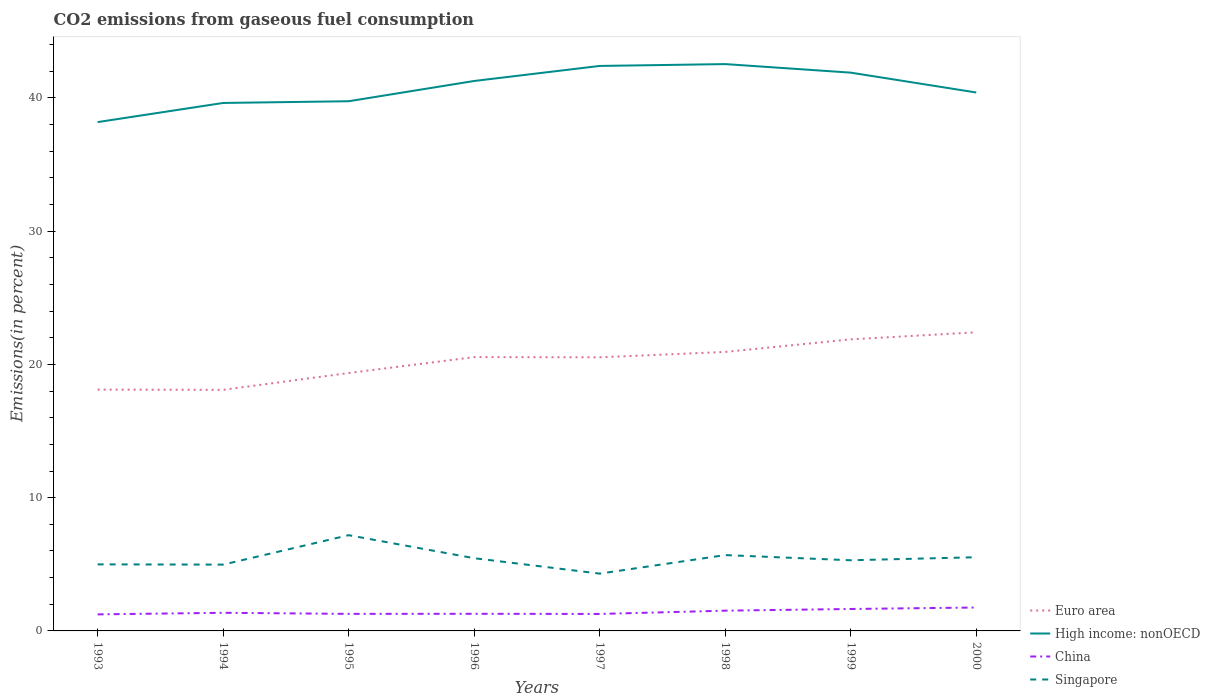How many different coloured lines are there?
Provide a short and direct response. 4. Does the line corresponding to High income: nonOECD intersect with the line corresponding to China?
Give a very brief answer. No. Across all years, what is the maximum total CO2 emitted in China?
Provide a short and direct response. 1.24. In which year was the total CO2 emitted in Euro area maximum?
Your response must be concise. 1994. What is the total total CO2 emitted in High income: nonOECD in the graph?
Offer a very short reply. -2.92. What is the difference between the highest and the second highest total CO2 emitted in High income: nonOECD?
Provide a short and direct response. 4.35. How many years are there in the graph?
Provide a succinct answer. 8. Are the values on the major ticks of Y-axis written in scientific E-notation?
Offer a very short reply. No. How many legend labels are there?
Offer a very short reply. 4. What is the title of the graph?
Make the answer very short. CO2 emissions from gaseous fuel consumption. What is the label or title of the X-axis?
Ensure brevity in your answer.  Years. What is the label or title of the Y-axis?
Give a very brief answer. Emissions(in percent). What is the Emissions(in percent) in Euro area in 1993?
Your answer should be compact. 18.11. What is the Emissions(in percent) of High income: nonOECD in 1993?
Your answer should be compact. 38.18. What is the Emissions(in percent) of China in 1993?
Keep it short and to the point. 1.24. What is the Emissions(in percent) of Singapore in 1993?
Give a very brief answer. 4.99. What is the Emissions(in percent) of Euro area in 1994?
Ensure brevity in your answer.  18.09. What is the Emissions(in percent) in High income: nonOECD in 1994?
Keep it short and to the point. 39.62. What is the Emissions(in percent) in China in 1994?
Offer a very short reply. 1.36. What is the Emissions(in percent) in Singapore in 1994?
Your response must be concise. 4.98. What is the Emissions(in percent) of Euro area in 1995?
Your answer should be compact. 19.35. What is the Emissions(in percent) of High income: nonOECD in 1995?
Give a very brief answer. 39.75. What is the Emissions(in percent) of China in 1995?
Ensure brevity in your answer.  1.28. What is the Emissions(in percent) of Singapore in 1995?
Keep it short and to the point. 7.18. What is the Emissions(in percent) of Euro area in 1996?
Keep it short and to the point. 20.55. What is the Emissions(in percent) of High income: nonOECD in 1996?
Offer a terse response. 41.27. What is the Emissions(in percent) in China in 1996?
Give a very brief answer. 1.29. What is the Emissions(in percent) of Singapore in 1996?
Your response must be concise. 5.46. What is the Emissions(in percent) of Euro area in 1997?
Offer a very short reply. 20.53. What is the Emissions(in percent) in High income: nonOECD in 1997?
Your answer should be compact. 42.4. What is the Emissions(in percent) of China in 1997?
Provide a short and direct response. 1.27. What is the Emissions(in percent) in Singapore in 1997?
Offer a terse response. 4.3. What is the Emissions(in percent) in Euro area in 1998?
Ensure brevity in your answer.  20.94. What is the Emissions(in percent) in High income: nonOECD in 1998?
Provide a short and direct response. 42.54. What is the Emissions(in percent) of China in 1998?
Make the answer very short. 1.52. What is the Emissions(in percent) of Singapore in 1998?
Offer a very short reply. 5.69. What is the Emissions(in percent) of Euro area in 1999?
Offer a very short reply. 21.88. What is the Emissions(in percent) of High income: nonOECD in 1999?
Keep it short and to the point. 41.89. What is the Emissions(in percent) in China in 1999?
Make the answer very short. 1.65. What is the Emissions(in percent) in Singapore in 1999?
Provide a succinct answer. 5.3. What is the Emissions(in percent) in Euro area in 2000?
Provide a short and direct response. 22.41. What is the Emissions(in percent) of High income: nonOECD in 2000?
Provide a short and direct response. 40.4. What is the Emissions(in percent) in China in 2000?
Ensure brevity in your answer.  1.76. What is the Emissions(in percent) in Singapore in 2000?
Make the answer very short. 5.53. Across all years, what is the maximum Emissions(in percent) in Euro area?
Give a very brief answer. 22.41. Across all years, what is the maximum Emissions(in percent) in High income: nonOECD?
Keep it short and to the point. 42.54. Across all years, what is the maximum Emissions(in percent) in China?
Ensure brevity in your answer.  1.76. Across all years, what is the maximum Emissions(in percent) of Singapore?
Give a very brief answer. 7.18. Across all years, what is the minimum Emissions(in percent) of Euro area?
Your answer should be very brief. 18.09. Across all years, what is the minimum Emissions(in percent) of High income: nonOECD?
Your answer should be very brief. 38.18. Across all years, what is the minimum Emissions(in percent) of China?
Your answer should be compact. 1.24. Across all years, what is the minimum Emissions(in percent) in Singapore?
Your answer should be compact. 4.3. What is the total Emissions(in percent) in Euro area in the graph?
Your answer should be compact. 161.86. What is the total Emissions(in percent) in High income: nonOECD in the graph?
Keep it short and to the point. 326.05. What is the total Emissions(in percent) of China in the graph?
Offer a terse response. 11.36. What is the total Emissions(in percent) of Singapore in the graph?
Ensure brevity in your answer.  43.43. What is the difference between the Emissions(in percent) of Euro area in 1993 and that in 1994?
Offer a terse response. 0.02. What is the difference between the Emissions(in percent) in High income: nonOECD in 1993 and that in 1994?
Your answer should be compact. -1.44. What is the difference between the Emissions(in percent) of China in 1993 and that in 1994?
Your response must be concise. -0.12. What is the difference between the Emissions(in percent) of Singapore in 1993 and that in 1994?
Offer a terse response. 0.02. What is the difference between the Emissions(in percent) of Euro area in 1993 and that in 1995?
Offer a terse response. -1.24. What is the difference between the Emissions(in percent) of High income: nonOECD in 1993 and that in 1995?
Your answer should be very brief. -1.57. What is the difference between the Emissions(in percent) in China in 1993 and that in 1995?
Your answer should be very brief. -0.04. What is the difference between the Emissions(in percent) of Singapore in 1993 and that in 1995?
Your response must be concise. -2.19. What is the difference between the Emissions(in percent) of Euro area in 1993 and that in 1996?
Provide a succinct answer. -2.44. What is the difference between the Emissions(in percent) in High income: nonOECD in 1993 and that in 1996?
Give a very brief answer. -3.09. What is the difference between the Emissions(in percent) in China in 1993 and that in 1996?
Give a very brief answer. -0.04. What is the difference between the Emissions(in percent) in Singapore in 1993 and that in 1996?
Offer a terse response. -0.46. What is the difference between the Emissions(in percent) of Euro area in 1993 and that in 1997?
Your answer should be very brief. -2.42. What is the difference between the Emissions(in percent) of High income: nonOECD in 1993 and that in 1997?
Your answer should be very brief. -4.22. What is the difference between the Emissions(in percent) in China in 1993 and that in 1997?
Keep it short and to the point. -0.03. What is the difference between the Emissions(in percent) of Singapore in 1993 and that in 1997?
Keep it short and to the point. 0.69. What is the difference between the Emissions(in percent) of Euro area in 1993 and that in 1998?
Offer a terse response. -2.83. What is the difference between the Emissions(in percent) in High income: nonOECD in 1993 and that in 1998?
Your answer should be very brief. -4.35. What is the difference between the Emissions(in percent) in China in 1993 and that in 1998?
Provide a short and direct response. -0.28. What is the difference between the Emissions(in percent) in Singapore in 1993 and that in 1998?
Your response must be concise. -0.7. What is the difference between the Emissions(in percent) in Euro area in 1993 and that in 1999?
Offer a terse response. -3.77. What is the difference between the Emissions(in percent) of High income: nonOECD in 1993 and that in 1999?
Your response must be concise. -3.71. What is the difference between the Emissions(in percent) in China in 1993 and that in 1999?
Ensure brevity in your answer.  -0.4. What is the difference between the Emissions(in percent) of Singapore in 1993 and that in 1999?
Make the answer very short. -0.31. What is the difference between the Emissions(in percent) in Euro area in 1993 and that in 2000?
Make the answer very short. -4.3. What is the difference between the Emissions(in percent) in High income: nonOECD in 1993 and that in 2000?
Give a very brief answer. -2.22. What is the difference between the Emissions(in percent) of China in 1993 and that in 2000?
Offer a very short reply. -0.52. What is the difference between the Emissions(in percent) in Singapore in 1993 and that in 2000?
Provide a succinct answer. -0.54. What is the difference between the Emissions(in percent) in Euro area in 1994 and that in 1995?
Make the answer very short. -1.26. What is the difference between the Emissions(in percent) in High income: nonOECD in 1994 and that in 1995?
Keep it short and to the point. -0.13. What is the difference between the Emissions(in percent) of China in 1994 and that in 1995?
Ensure brevity in your answer.  0.08. What is the difference between the Emissions(in percent) in Singapore in 1994 and that in 1995?
Provide a short and direct response. -2.21. What is the difference between the Emissions(in percent) of Euro area in 1994 and that in 1996?
Ensure brevity in your answer.  -2.46. What is the difference between the Emissions(in percent) in High income: nonOECD in 1994 and that in 1996?
Keep it short and to the point. -1.65. What is the difference between the Emissions(in percent) in China in 1994 and that in 1996?
Provide a succinct answer. 0.08. What is the difference between the Emissions(in percent) of Singapore in 1994 and that in 1996?
Keep it short and to the point. -0.48. What is the difference between the Emissions(in percent) of Euro area in 1994 and that in 1997?
Offer a very short reply. -2.44. What is the difference between the Emissions(in percent) of High income: nonOECD in 1994 and that in 1997?
Ensure brevity in your answer.  -2.78. What is the difference between the Emissions(in percent) in China in 1994 and that in 1997?
Offer a terse response. 0.09. What is the difference between the Emissions(in percent) in Singapore in 1994 and that in 1997?
Your answer should be very brief. 0.68. What is the difference between the Emissions(in percent) of Euro area in 1994 and that in 1998?
Your response must be concise. -2.84. What is the difference between the Emissions(in percent) in High income: nonOECD in 1994 and that in 1998?
Keep it short and to the point. -2.92. What is the difference between the Emissions(in percent) of China in 1994 and that in 1998?
Provide a short and direct response. -0.16. What is the difference between the Emissions(in percent) of Singapore in 1994 and that in 1998?
Make the answer very short. -0.71. What is the difference between the Emissions(in percent) in Euro area in 1994 and that in 1999?
Offer a terse response. -3.79. What is the difference between the Emissions(in percent) in High income: nonOECD in 1994 and that in 1999?
Offer a very short reply. -2.28. What is the difference between the Emissions(in percent) of China in 1994 and that in 1999?
Your answer should be very brief. -0.29. What is the difference between the Emissions(in percent) in Singapore in 1994 and that in 1999?
Your answer should be compact. -0.33. What is the difference between the Emissions(in percent) of Euro area in 1994 and that in 2000?
Your answer should be compact. -4.31. What is the difference between the Emissions(in percent) of High income: nonOECD in 1994 and that in 2000?
Give a very brief answer. -0.78. What is the difference between the Emissions(in percent) of China in 1994 and that in 2000?
Provide a succinct answer. -0.4. What is the difference between the Emissions(in percent) in Singapore in 1994 and that in 2000?
Give a very brief answer. -0.55. What is the difference between the Emissions(in percent) in Euro area in 1995 and that in 1996?
Your answer should be compact. -1.2. What is the difference between the Emissions(in percent) of High income: nonOECD in 1995 and that in 1996?
Make the answer very short. -1.52. What is the difference between the Emissions(in percent) in China in 1995 and that in 1996?
Your answer should be compact. -0.01. What is the difference between the Emissions(in percent) in Singapore in 1995 and that in 1996?
Provide a succinct answer. 1.73. What is the difference between the Emissions(in percent) in Euro area in 1995 and that in 1997?
Ensure brevity in your answer.  -1.18. What is the difference between the Emissions(in percent) of High income: nonOECD in 1995 and that in 1997?
Provide a short and direct response. -2.65. What is the difference between the Emissions(in percent) in China in 1995 and that in 1997?
Provide a short and direct response. 0.01. What is the difference between the Emissions(in percent) of Singapore in 1995 and that in 1997?
Give a very brief answer. 2.88. What is the difference between the Emissions(in percent) of Euro area in 1995 and that in 1998?
Your answer should be compact. -1.58. What is the difference between the Emissions(in percent) in High income: nonOECD in 1995 and that in 1998?
Offer a very short reply. -2.79. What is the difference between the Emissions(in percent) in China in 1995 and that in 1998?
Your answer should be compact. -0.24. What is the difference between the Emissions(in percent) in Singapore in 1995 and that in 1998?
Provide a succinct answer. 1.49. What is the difference between the Emissions(in percent) in Euro area in 1995 and that in 1999?
Provide a short and direct response. -2.53. What is the difference between the Emissions(in percent) of High income: nonOECD in 1995 and that in 1999?
Your answer should be compact. -2.15. What is the difference between the Emissions(in percent) of China in 1995 and that in 1999?
Offer a terse response. -0.37. What is the difference between the Emissions(in percent) in Singapore in 1995 and that in 1999?
Your answer should be compact. 1.88. What is the difference between the Emissions(in percent) in Euro area in 1995 and that in 2000?
Make the answer very short. -3.05. What is the difference between the Emissions(in percent) in High income: nonOECD in 1995 and that in 2000?
Your answer should be very brief. -0.66. What is the difference between the Emissions(in percent) of China in 1995 and that in 2000?
Your response must be concise. -0.48. What is the difference between the Emissions(in percent) of Singapore in 1995 and that in 2000?
Your response must be concise. 1.65. What is the difference between the Emissions(in percent) in Euro area in 1996 and that in 1997?
Offer a very short reply. 0.02. What is the difference between the Emissions(in percent) in High income: nonOECD in 1996 and that in 1997?
Ensure brevity in your answer.  -1.13. What is the difference between the Emissions(in percent) of China in 1996 and that in 1997?
Make the answer very short. 0.01. What is the difference between the Emissions(in percent) in Singapore in 1996 and that in 1997?
Your answer should be very brief. 1.16. What is the difference between the Emissions(in percent) in Euro area in 1996 and that in 1998?
Your answer should be very brief. -0.39. What is the difference between the Emissions(in percent) in High income: nonOECD in 1996 and that in 1998?
Ensure brevity in your answer.  -1.27. What is the difference between the Emissions(in percent) in China in 1996 and that in 1998?
Your answer should be compact. -0.24. What is the difference between the Emissions(in percent) of Singapore in 1996 and that in 1998?
Your answer should be very brief. -0.23. What is the difference between the Emissions(in percent) of Euro area in 1996 and that in 1999?
Give a very brief answer. -1.33. What is the difference between the Emissions(in percent) in High income: nonOECD in 1996 and that in 1999?
Your answer should be very brief. -0.63. What is the difference between the Emissions(in percent) of China in 1996 and that in 1999?
Make the answer very short. -0.36. What is the difference between the Emissions(in percent) in Singapore in 1996 and that in 1999?
Make the answer very short. 0.15. What is the difference between the Emissions(in percent) in Euro area in 1996 and that in 2000?
Your answer should be compact. -1.86. What is the difference between the Emissions(in percent) of High income: nonOECD in 1996 and that in 2000?
Keep it short and to the point. 0.86. What is the difference between the Emissions(in percent) in China in 1996 and that in 2000?
Your answer should be very brief. -0.47. What is the difference between the Emissions(in percent) in Singapore in 1996 and that in 2000?
Offer a terse response. -0.07. What is the difference between the Emissions(in percent) of Euro area in 1997 and that in 1998?
Your answer should be very brief. -0.4. What is the difference between the Emissions(in percent) of High income: nonOECD in 1997 and that in 1998?
Offer a terse response. -0.14. What is the difference between the Emissions(in percent) of China in 1997 and that in 1998?
Your response must be concise. -0.25. What is the difference between the Emissions(in percent) in Singapore in 1997 and that in 1998?
Your response must be concise. -1.39. What is the difference between the Emissions(in percent) of Euro area in 1997 and that in 1999?
Provide a succinct answer. -1.35. What is the difference between the Emissions(in percent) of High income: nonOECD in 1997 and that in 1999?
Keep it short and to the point. 0.5. What is the difference between the Emissions(in percent) of China in 1997 and that in 1999?
Your answer should be very brief. -0.37. What is the difference between the Emissions(in percent) in Singapore in 1997 and that in 1999?
Your answer should be compact. -1. What is the difference between the Emissions(in percent) of Euro area in 1997 and that in 2000?
Your answer should be very brief. -1.87. What is the difference between the Emissions(in percent) in High income: nonOECD in 1997 and that in 2000?
Your answer should be very brief. 1.99. What is the difference between the Emissions(in percent) in China in 1997 and that in 2000?
Offer a terse response. -0.48. What is the difference between the Emissions(in percent) of Singapore in 1997 and that in 2000?
Ensure brevity in your answer.  -1.23. What is the difference between the Emissions(in percent) of Euro area in 1998 and that in 1999?
Your answer should be compact. -0.94. What is the difference between the Emissions(in percent) of High income: nonOECD in 1998 and that in 1999?
Provide a succinct answer. 0.64. What is the difference between the Emissions(in percent) in China in 1998 and that in 1999?
Offer a terse response. -0.13. What is the difference between the Emissions(in percent) in Singapore in 1998 and that in 1999?
Provide a succinct answer. 0.39. What is the difference between the Emissions(in percent) in Euro area in 1998 and that in 2000?
Ensure brevity in your answer.  -1.47. What is the difference between the Emissions(in percent) of High income: nonOECD in 1998 and that in 2000?
Offer a very short reply. 2.13. What is the difference between the Emissions(in percent) in China in 1998 and that in 2000?
Your response must be concise. -0.24. What is the difference between the Emissions(in percent) in Singapore in 1998 and that in 2000?
Give a very brief answer. 0.16. What is the difference between the Emissions(in percent) in Euro area in 1999 and that in 2000?
Your response must be concise. -0.53. What is the difference between the Emissions(in percent) in High income: nonOECD in 1999 and that in 2000?
Keep it short and to the point. 1.49. What is the difference between the Emissions(in percent) of China in 1999 and that in 2000?
Offer a terse response. -0.11. What is the difference between the Emissions(in percent) of Singapore in 1999 and that in 2000?
Your answer should be very brief. -0.23. What is the difference between the Emissions(in percent) in Euro area in 1993 and the Emissions(in percent) in High income: nonOECD in 1994?
Offer a very short reply. -21.51. What is the difference between the Emissions(in percent) in Euro area in 1993 and the Emissions(in percent) in China in 1994?
Offer a very short reply. 16.75. What is the difference between the Emissions(in percent) of Euro area in 1993 and the Emissions(in percent) of Singapore in 1994?
Your answer should be very brief. 13.13. What is the difference between the Emissions(in percent) of High income: nonOECD in 1993 and the Emissions(in percent) of China in 1994?
Make the answer very short. 36.82. What is the difference between the Emissions(in percent) of High income: nonOECD in 1993 and the Emissions(in percent) of Singapore in 1994?
Your answer should be very brief. 33.21. What is the difference between the Emissions(in percent) of China in 1993 and the Emissions(in percent) of Singapore in 1994?
Ensure brevity in your answer.  -3.73. What is the difference between the Emissions(in percent) in Euro area in 1993 and the Emissions(in percent) in High income: nonOECD in 1995?
Give a very brief answer. -21.64. What is the difference between the Emissions(in percent) of Euro area in 1993 and the Emissions(in percent) of China in 1995?
Ensure brevity in your answer.  16.83. What is the difference between the Emissions(in percent) in Euro area in 1993 and the Emissions(in percent) in Singapore in 1995?
Offer a terse response. 10.92. What is the difference between the Emissions(in percent) of High income: nonOECD in 1993 and the Emissions(in percent) of China in 1995?
Your answer should be very brief. 36.9. What is the difference between the Emissions(in percent) in High income: nonOECD in 1993 and the Emissions(in percent) in Singapore in 1995?
Provide a short and direct response. 31. What is the difference between the Emissions(in percent) in China in 1993 and the Emissions(in percent) in Singapore in 1995?
Offer a very short reply. -5.94. What is the difference between the Emissions(in percent) of Euro area in 1993 and the Emissions(in percent) of High income: nonOECD in 1996?
Offer a terse response. -23.16. What is the difference between the Emissions(in percent) of Euro area in 1993 and the Emissions(in percent) of China in 1996?
Keep it short and to the point. 16.82. What is the difference between the Emissions(in percent) of Euro area in 1993 and the Emissions(in percent) of Singapore in 1996?
Make the answer very short. 12.65. What is the difference between the Emissions(in percent) in High income: nonOECD in 1993 and the Emissions(in percent) in China in 1996?
Your answer should be very brief. 36.9. What is the difference between the Emissions(in percent) in High income: nonOECD in 1993 and the Emissions(in percent) in Singapore in 1996?
Offer a very short reply. 32.73. What is the difference between the Emissions(in percent) in China in 1993 and the Emissions(in percent) in Singapore in 1996?
Provide a short and direct response. -4.21. What is the difference between the Emissions(in percent) in Euro area in 1993 and the Emissions(in percent) in High income: nonOECD in 1997?
Provide a short and direct response. -24.29. What is the difference between the Emissions(in percent) of Euro area in 1993 and the Emissions(in percent) of China in 1997?
Ensure brevity in your answer.  16.83. What is the difference between the Emissions(in percent) of Euro area in 1993 and the Emissions(in percent) of Singapore in 1997?
Your response must be concise. 13.81. What is the difference between the Emissions(in percent) in High income: nonOECD in 1993 and the Emissions(in percent) in China in 1997?
Your response must be concise. 36.91. What is the difference between the Emissions(in percent) in High income: nonOECD in 1993 and the Emissions(in percent) in Singapore in 1997?
Keep it short and to the point. 33.88. What is the difference between the Emissions(in percent) in China in 1993 and the Emissions(in percent) in Singapore in 1997?
Give a very brief answer. -3.06. What is the difference between the Emissions(in percent) of Euro area in 1993 and the Emissions(in percent) of High income: nonOECD in 1998?
Keep it short and to the point. -24.43. What is the difference between the Emissions(in percent) of Euro area in 1993 and the Emissions(in percent) of China in 1998?
Give a very brief answer. 16.59. What is the difference between the Emissions(in percent) of Euro area in 1993 and the Emissions(in percent) of Singapore in 1998?
Your answer should be compact. 12.42. What is the difference between the Emissions(in percent) in High income: nonOECD in 1993 and the Emissions(in percent) in China in 1998?
Ensure brevity in your answer.  36.66. What is the difference between the Emissions(in percent) in High income: nonOECD in 1993 and the Emissions(in percent) in Singapore in 1998?
Your response must be concise. 32.49. What is the difference between the Emissions(in percent) of China in 1993 and the Emissions(in percent) of Singapore in 1998?
Offer a terse response. -4.45. What is the difference between the Emissions(in percent) of Euro area in 1993 and the Emissions(in percent) of High income: nonOECD in 1999?
Offer a terse response. -23.79. What is the difference between the Emissions(in percent) of Euro area in 1993 and the Emissions(in percent) of China in 1999?
Your answer should be very brief. 16.46. What is the difference between the Emissions(in percent) in Euro area in 1993 and the Emissions(in percent) in Singapore in 1999?
Keep it short and to the point. 12.81. What is the difference between the Emissions(in percent) in High income: nonOECD in 1993 and the Emissions(in percent) in China in 1999?
Ensure brevity in your answer.  36.54. What is the difference between the Emissions(in percent) of High income: nonOECD in 1993 and the Emissions(in percent) of Singapore in 1999?
Give a very brief answer. 32.88. What is the difference between the Emissions(in percent) of China in 1993 and the Emissions(in percent) of Singapore in 1999?
Your answer should be compact. -4.06. What is the difference between the Emissions(in percent) of Euro area in 1993 and the Emissions(in percent) of High income: nonOECD in 2000?
Your answer should be compact. -22.3. What is the difference between the Emissions(in percent) in Euro area in 1993 and the Emissions(in percent) in China in 2000?
Keep it short and to the point. 16.35. What is the difference between the Emissions(in percent) in Euro area in 1993 and the Emissions(in percent) in Singapore in 2000?
Your answer should be very brief. 12.58. What is the difference between the Emissions(in percent) of High income: nonOECD in 1993 and the Emissions(in percent) of China in 2000?
Provide a succinct answer. 36.43. What is the difference between the Emissions(in percent) of High income: nonOECD in 1993 and the Emissions(in percent) of Singapore in 2000?
Provide a succinct answer. 32.65. What is the difference between the Emissions(in percent) of China in 1993 and the Emissions(in percent) of Singapore in 2000?
Keep it short and to the point. -4.29. What is the difference between the Emissions(in percent) in Euro area in 1994 and the Emissions(in percent) in High income: nonOECD in 1995?
Your answer should be compact. -21.66. What is the difference between the Emissions(in percent) in Euro area in 1994 and the Emissions(in percent) in China in 1995?
Offer a terse response. 16.81. What is the difference between the Emissions(in percent) of Euro area in 1994 and the Emissions(in percent) of Singapore in 1995?
Your answer should be very brief. 10.91. What is the difference between the Emissions(in percent) in High income: nonOECD in 1994 and the Emissions(in percent) in China in 1995?
Provide a short and direct response. 38.34. What is the difference between the Emissions(in percent) of High income: nonOECD in 1994 and the Emissions(in percent) of Singapore in 1995?
Provide a succinct answer. 32.44. What is the difference between the Emissions(in percent) of China in 1994 and the Emissions(in percent) of Singapore in 1995?
Provide a short and direct response. -5.82. What is the difference between the Emissions(in percent) of Euro area in 1994 and the Emissions(in percent) of High income: nonOECD in 1996?
Offer a very short reply. -23.18. What is the difference between the Emissions(in percent) of Euro area in 1994 and the Emissions(in percent) of China in 1996?
Ensure brevity in your answer.  16.81. What is the difference between the Emissions(in percent) of Euro area in 1994 and the Emissions(in percent) of Singapore in 1996?
Your answer should be very brief. 12.64. What is the difference between the Emissions(in percent) in High income: nonOECD in 1994 and the Emissions(in percent) in China in 1996?
Your answer should be compact. 38.33. What is the difference between the Emissions(in percent) of High income: nonOECD in 1994 and the Emissions(in percent) of Singapore in 1996?
Ensure brevity in your answer.  34.16. What is the difference between the Emissions(in percent) of China in 1994 and the Emissions(in percent) of Singapore in 1996?
Your response must be concise. -4.1. What is the difference between the Emissions(in percent) of Euro area in 1994 and the Emissions(in percent) of High income: nonOECD in 1997?
Offer a terse response. -24.31. What is the difference between the Emissions(in percent) of Euro area in 1994 and the Emissions(in percent) of China in 1997?
Your response must be concise. 16.82. What is the difference between the Emissions(in percent) of Euro area in 1994 and the Emissions(in percent) of Singapore in 1997?
Your answer should be very brief. 13.79. What is the difference between the Emissions(in percent) in High income: nonOECD in 1994 and the Emissions(in percent) in China in 1997?
Provide a short and direct response. 38.35. What is the difference between the Emissions(in percent) in High income: nonOECD in 1994 and the Emissions(in percent) in Singapore in 1997?
Offer a terse response. 35.32. What is the difference between the Emissions(in percent) of China in 1994 and the Emissions(in percent) of Singapore in 1997?
Make the answer very short. -2.94. What is the difference between the Emissions(in percent) of Euro area in 1994 and the Emissions(in percent) of High income: nonOECD in 1998?
Make the answer very short. -24.44. What is the difference between the Emissions(in percent) of Euro area in 1994 and the Emissions(in percent) of China in 1998?
Provide a short and direct response. 16.57. What is the difference between the Emissions(in percent) in Euro area in 1994 and the Emissions(in percent) in Singapore in 1998?
Your answer should be very brief. 12.4. What is the difference between the Emissions(in percent) of High income: nonOECD in 1994 and the Emissions(in percent) of China in 1998?
Provide a short and direct response. 38.1. What is the difference between the Emissions(in percent) of High income: nonOECD in 1994 and the Emissions(in percent) of Singapore in 1998?
Your answer should be compact. 33.93. What is the difference between the Emissions(in percent) in China in 1994 and the Emissions(in percent) in Singapore in 1998?
Give a very brief answer. -4.33. What is the difference between the Emissions(in percent) in Euro area in 1994 and the Emissions(in percent) in High income: nonOECD in 1999?
Make the answer very short. -23.8. What is the difference between the Emissions(in percent) in Euro area in 1994 and the Emissions(in percent) in China in 1999?
Ensure brevity in your answer.  16.45. What is the difference between the Emissions(in percent) of Euro area in 1994 and the Emissions(in percent) of Singapore in 1999?
Offer a terse response. 12.79. What is the difference between the Emissions(in percent) of High income: nonOECD in 1994 and the Emissions(in percent) of China in 1999?
Offer a very short reply. 37.97. What is the difference between the Emissions(in percent) in High income: nonOECD in 1994 and the Emissions(in percent) in Singapore in 1999?
Make the answer very short. 34.32. What is the difference between the Emissions(in percent) in China in 1994 and the Emissions(in percent) in Singapore in 1999?
Your response must be concise. -3.94. What is the difference between the Emissions(in percent) in Euro area in 1994 and the Emissions(in percent) in High income: nonOECD in 2000?
Provide a succinct answer. -22.31. What is the difference between the Emissions(in percent) of Euro area in 1994 and the Emissions(in percent) of China in 2000?
Your response must be concise. 16.33. What is the difference between the Emissions(in percent) of Euro area in 1994 and the Emissions(in percent) of Singapore in 2000?
Your answer should be very brief. 12.56. What is the difference between the Emissions(in percent) in High income: nonOECD in 1994 and the Emissions(in percent) in China in 2000?
Provide a short and direct response. 37.86. What is the difference between the Emissions(in percent) of High income: nonOECD in 1994 and the Emissions(in percent) of Singapore in 2000?
Offer a very short reply. 34.09. What is the difference between the Emissions(in percent) in China in 1994 and the Emissions(in percent) in Singapore in 2000?
Provide a short and direct response. -4.17. What is the difference between the Emissions(in percent) of Euro area in 1995 and the Emissions(in percent) of High income: nonOECD in 1996?
Keep it short and to the point. -21.92. What is the difference between the Emissions(in percent) of Euro area in 1995 and the Emissions(in percent) of China in 1996?
Provide a short and direct response. 18.07. What is the difference between the Emissions(in percent) of Euro area in 1995 and the Emissions(in percent) of Singapore in 1996?
Offer a terse response. 13.9. What is the difference between the Emissions(in percent) in High income: nonOECD in 1995 and the Emissions(in percent) in China in 1996?
Offer a very short reply. 38.46. What is the difference between the Emissions(in percent) of High income: nonOECD in 1995 and the Emissions(in percent) of Singapore in 1996?
Your answer should be very brief. 34.29. What is the difference between the Emissions(in percent) in China in 1995 and the Emissions(in percent) in Singapore in 1996?
Your answer should be compact. -4.18. What is the difference between the Emissions(in percent) of Euro area in 1995 and the Emissions(in percent) of High income: nonOECD in 1997?
Your answer should be compact. -23.05. What is the difference between the Emissions(in percent) of Euro area in 1995 and the Emissions(in percent) of China in 1997?
Offer a very short reply. 18.08. What is the difference between the Emissions(in percent) in Euro area in 1995 and the Emissions(in percent) in Singapore in 1997?
Ensure brevity in your answer.  15.05. What is the difference between the Emissions(in percent) of High income: nonOECD in 1995 and the Emissions(in percent) of China in 1997?
Provide a succinct answer. 38.48. What is the difference between the Emissions(in percent) of High income: nonOECD in 1995 and the Emissions(in percent) of Singapore in 1997?
Make the answer very short. 35.45. What is the difference between the Emissions(in percent) in China in 1995 and the Emissions(in percent) in Singapore in 1997?
Keep it short and to the point. -3.02. What is the difference between the Emissions(in percent) in Euro area in 1995 and the Emissions(in percent) in High income: nonOECD in 1998?
Offer a very short reply. -23.18. What is the difference between the Emissions(in percent) in Euro area in 1995 and the Emissions(in percent) in China in 1998?
Your answer should be compact. 17.83. What is the difference between the Emissions(in percent) of Euro area in 1995 and the Emissions(in percent) of Singapore in 1998?
Provide a short and direct response. 13.66. What is the difference between the Emissions(in percent) in High income: nonOECD in 1995 and the Emissions(in percent) in China in 1998?
Keep it short and to the point. 38.23. What is the difference between the Emissions(in percent) of High income: nonOECD in 1995 and the Emissions(in percent) of Singapore in 1998?
Your answer should be very brief. 34.06. What is the difference between the Emissions(in percent) in China in 1995 and the Emissions(in percent) in Singapore in 1998?
Provide a succinct answer. -4.41. What is the difference between the Emissions(in percent) of Euro area in 1995 and the Emissions(in percent) of High income: nonOECD in 1999?
Provide a succinct answer. -22.54. What is the difference between the Emissions(in percent) of Euro area in 1995 and the Emissions(in percent) of China in 1999?
Offer a very short reply. 17.71. What is the difference between the Emissions(in percent) in Euro area in 1995 and the Emissions(in percent) in Singapore in 1999?
Make the answer very short. 14.05. What is the difference between the Emissions(in percent) in High income: nonOECD in 1995 and the Emissions(in percent) in China in 1999?
Give a very brief answer. 38.1. What is the difference between the Emissions(in percent) of High income: nonOECD in 1995 and the Emissions(in percent) of Singapore in 1999?
Your answer should be very brief. 34.45. What is the difference between the Emissions(in percent) of China in 1995 and the Emissions(in percent) of Singapore in 1999?
Your answer should be very brief. -4.02. What is the difference between the Emissions(in percent) of Euro area in 1995 and the Emissions(in percent) of High income: nonOECD in 2000?
Provide a short and direct response. -21.05. What is the difference between the Emissions(in percent) in Euro area in 1995 and the Emissions(in percent) in China in 2000?
Your answer should be compact. 17.6. What is the difference between the Emissions(in percent) of Euro area in 1995 and the Emissions(in percent) of Singapore in 2000?
Your response must be concise. 13.82. What is the difference between the Emissions(in percent) in High income: nonOECD in 1995 and the Emissions(in percent) in China in 2000?
Give a very brief answer. 37.99. What is the difference between the Emissions(in percent) of High income: nonOECD in 1995 and the Emissions(in percent) of Singapore in 2000?
Offer a terse response. 34.22. What is the difference between the Emissions(in percent) in China in 1995 and the Emissions(in percent) in Singapore in 2000?
Give a very brief answer. -4.25. What is the difference between the Emissions(in percent) of Euro area in 1996 and the Emissions(in percent) of High income: nonOECD in 1997?
Offer a terse response. -21.85. What is the difference between the Emissions(in percent) of Euro area in 1996 and the Emissions(in percent) of China in 1997?
Your answer should be very brief. 19.27. What is the difference between the Emissions(in percent) in Euro area in 1996 and the Emissions(in percent) in Singapore in 1997?
Provide a short and direct response. 16.25. What is the difference between the Emissions(in percent) in High income: nonOECD in 1996 and the Emissions(in percent) in China in 1997?
Offer a terse response. 39.99. What is the difference between the Emissions(in percent) of High income: nonOECD in 1996 and the Emissions(in percent) of Singapore in 1997?
Give a very brief answer. 36.97. What is the difference between the Emissions(in percent) in China in 1996 and the Emissions(in percent) in Singapore in 1997?
Ensure brevity in your answer.  -3.02. What is the difference between the Emissions(in percent) of Euro area in 1996 and the Emissions(in percent) of High income: nonOECD in 1998?
Provide a short and direct response. -21.99. What is the difference between the Emissions(in percent) in Euro area in 1996 and the Emissions(in percent) in China in 1998?
Ensure brevity in your answer.  19.03. What is the difference between the Emissions(in percent) of Euro area in 1996 and the Emissions(in percent) of Singapore in 1998?
Offer a very short reply. 14.86. What is the difference between the Emissions(in percent) in High income: nonOECD in 1996 and the Emissions(in percent) in China in 1998?
Ensure brevity in your answer.  39.75. What is the difference between the Emissions(in percent) in High income: nonOECD in 1996 and the Emissions(in percent) in Singapore in 1998?
Provide a short and direct response. 35.58. What is the difference between the Emissions(in percent) of China in 1996 and the Emissions(in percent) of Singapore in 1998?
Keep it short and to the point. -4.4. What is the difference between the Emissions(in percent) in Euro area in 1996 and the Emissions(in percent) in High income: nonOECD in 1999?
Your answer should be very brief. -21.35. What is the difference between the Emissions(in percent) in Euro area in 1996 and the Emissions(in percent) in China in 1999?
Provide a succinct answer. 18.9. What is the difference between the Emissions(in percent) of Euro area in 1996 and the Emissions(in percent) of Singapore in 1999?
Your response must be concise. 15.25. What is the difference between the Emissions(in percent) in High income: nonOECD in 1996 and the Emissions(in percent) in China in 1999?
Offer a terse response. 39.62. What is the difference between the Emissions(in percent) in High income: nonOECD in 1996 and the Emissions(in percent) in Singapore in 1999?
Ensure brevity in your answer.  35.97. What is the difference between the Emissions(in percent) in China in 1996 and the Emissions(in percent) in Singapore in 1999?
Provide a succinct answer. -4.02. What is the difference between the Emissions(in percent) of Euro area in 1996 and the Emissions(in percent) of High income: nonOECD in 2000?
Keep it short and to the point. -19.86. What is the difference between the Emissions(in percent) in Euro area in 1996 and the Emissions(in percent) in China in 2000?
Provide a short and direct response. 18.79. What is the difference between the Emissions(in percent) in Euro area in 1996 and the Emissions(in percent) in Singapore in 2000?
Your answer should be very brief. 15.02. What is the difference between the Emissions(in percent) in High income: nonOECD in 1996 and the Emissions(in percent) in China in 2000?
Your answer should be compact. 39.51. What is the difference between the Emissions(in percent) in High income: nonOECD in 1996 and the Emissions(in percent) in Singapore in 2000?
Keep it short and to the point. 35.74. What is the difference between the Emissions(in percent) of China in 1996 and the Emissions(in percent) of Singapore in 2000?
Give a very brief answer. -4.24. What is the difference between the Emissions(in percent) in Euro area in 1997 and the Emissions(in percent) in High income: nonOECD in 1998?
Your answer should be very brief. -22. What is the difference between the Emissions(in percent) in Euro area in 1997 and the Emissions(in percent) in China in 1998?
Your response must be concise. 19.01. What is the difference between the Emissions(in percent) in Euro area in 1997 and the Emissions(in percent) in Singapore in 1998?
Your response must be concise. 14.84. What is the difference between the Emissions(in percent) in High income: nonOECD in 1997 and the Emissions(in percent) in China in 1998?
Make the answer very short. 40.88. What is the difference between the Emissions(in percent) of High income: nonOECD in 1997 and the Emissions(in percent) of Singapore in 1998?
Offer a terse response. 36.71. What is the difference between the Emissions(in percent) in China in 1997 and the Emissions(in percent) in Singapore in 1998?
Provide a short and direct response. -4.42. What is the difference between the Emissions(in percent) in Euro area in 1997 and the Emissions(in percent) in High income: nonOECD in 1999?
Your response must be concise. -21.36. What is the difference between the Emissions(in percent) in Euro area in 1997 and the Emissions(in percent) in China in 1999?
Provide a succinct answer. 18.89. What is the difference between the Emissions(in percent) in Euro area in 1997 and the Emissions(in percent) in Singapore in 1999?
Provide a short and direct response. 15.23. What is the difference between the Emissions(in percent) of High income: nonOECD in 1997 and the Emissions(in percent) of China in 1999?
Offer a terse response. 40.75. What is the difference between the Emissions(in percent) of High income: nonOECD in 1997 and the Emissions(in percent) of Singapore in 1999?
Make the answer very short. 37.1. What is the difference between the Emissions(in percent) in China in 1997 and the Emissions(in percent) in Singapore in 1999?
Make the answer very short. -4.03. What is the difference between the Emissions(in percent) in Euro area in 1997 and the Emissions(in percent) in High income: nonOECD in 2000?
Offer a very short reply. -19.87. What is the difference between the Emissions(in percent) in Euro area in 1997 and the Emissions(in percent) in China in 2000?
Your answer should be compact. 18.77. What is the difference between the Emissions(in percent) of Euro area in 1997 and the Emissions(in percent) of Singapore in 2000?
Make the answer very short. 15. What is the difference between the Emissions(in percent) in High income: nonOECD in 1997 and the Emissions(in percent) in China in 2000?
Make the answer very short. 40.64. What is the difference between the Emissions(in percent) in High income: nonOECD in 1997 and the Emissions(in percent) in Singapore in 2000?
Provide a short and direct response. 36.87. What is the difference between the Emissions(in percent) in China in 1997 and the Emissions(in percent) in Singapore in 2000?
Keep it short and to the point. -4.26. What is the difference between the Emissions(in percent) of Euro area in 1998 and the Emissions(in percent) of High income: nonOECD in 1999?
Make the answer very short. -20.96. What is the difference between the Emissions(in percent) of Euro area in 1998 and the Emissions(in percent) of China in 1999?
Offer a terse response. 19.29. What is the difference between the Emissions(in percent) in Euro area in 1998 and the Emissions(in percent) in Singapore in 1999?
Offer a terse response. 15.63. What is the difference between the Emissions(in percent) in High income: nonOECD in 1998 and the Emissions(in percent) in China in 1999?
Your answer should be compact. 40.89. What is the difference between the Emissions(in percent) in High income: nonOECD in 1998 and the Emissions(in percent) in Singapore in 1999?
Provide a succinct answer. 37.23. What is the difference between the Emissions(in percent) in China in 1998 and the Emissions(in percent) in Singapore in 1999?
Your answer should be compact. -3.78. What is the difference between the Emissions(in percent) in Euro area in 1998 and the Emissions(in percent) in High income: nonOECD in 2000?
Provide a succinct answer. -19.47. What is the difference between the Emissions(in percent) in Euro area in 1998 and the Emissions(in percent) in China in 2000?
Provide a succinct answer. 19.18. What is the difference between the Emissions(in percent) of Euro area in 1998 and the Emissions(in percent) of Singapore in 2000?
Ensure brevity in your answer.  15.41. What is the difference between the Emissions(in percent) of High income: nonOECD in 1998 and the Emissions(in percent) of China in 2000?
Offer a terse response. 40.78. What is the difference between the Emissions(in percent) in High income: nonOECD in 1998 and the Emissions(in percent) in Singapore in 2000?
Make the answer very short. 37.01. What is the difference between the Emissions(in percent) of China in 1998 and the Emissions(in percent) of Singapore in 2000?
Your response must be concise. -4.01. What is the difference between the Emissions(in percent) in Euro area in 1999 and the Emissions(in percent) in High income: nonOECD in 2000?
Offer a very short reply. -18.52. What is the difference between the Emissions(in percent) of Euro area in 1999 and the Emissions(in percent) of China in 2000?
Your response must be concise. 20.12. What is the difference between the Emissions(in percent) in Euro area in 1999 and the Emissions(in percent) in Singapore in 2000?
Provide a short and direct response. 16.35. What is the difference between the Emissions(in percent) of High income: nonOECD in 1999 and the Emissions(in percent) of China in 2000?
Your response must be concise. 40.14. What is the difference between the Emissions(in percent) of High income: nonOECD in 1999 and the Emissions(in percent) of Singapore in 2000?
Provide a short and direct response. 36.37. What is the difference between the Emissions(in percent) of China in 1999 and the Emissions(in percent) of Singapore in 2000?
Keep it short and to the point. -3.88. What is the average Emissions(in percent) in Euro area per year?
Give a very brief answer. 20.23. What is the average Emissions(in percent) in High income: nonOECD per year?
Give a very brief answer. 40.76. What is the average Emissions(in percent) of China per year?
Offer a terse response. 1.42. What is the average Emissions(in percent) of Singapore per year?
Ensure brevity in your answer.  5.43. In the year 1993, what is the difference between the Emissions(in percent) in Euro area and Emissions(in percent) in High income: nonOECD?
Your answer should be compact. -20.07. In the year 1993, what is the difference between the Emissions(in percent) in Euro area and Emissions(in percent) in China?
Your response must be concise. 16.87. In the year 1993, what is the difference between the Emissions(in percent) in Euro area and Emissions(in percent) in Singapore?
Offer a very short reply. 13.11. In the year 1993, what is the difference between the Emissions(in percent) in High income: nonOECD and Emissions(in percent) in China?
Offer a very short reply. 36.94. In the year 1993, what is the difference between the Emissions(in percent) in High income: nonOECD and Emissions(in percent) in Singapore?
Offer a terse response. 33.19. In the year 1993, what is the difference between the Emissions(in percent) of China and Emissions(in percent) of Singapore?
Your answer should be very brief. -3.75. In the year 1994, what is the difference between the Emissions(in percent) of Euro area and Emissions(in percent) of High income: nonOECD?
Make the answer very short. -21.53. In the year 1994, what is the difference between the Emissions(in percent) of Euro area and Emissions(in percent) of China?
Ensure brevity in your answer.  16.73. In the year 1994, what is the difference between the Emissions(in percent) of Euro area and Emissions(in percent) of Singapore?
Your answer should be compact. 13.12. In the year 1994, what is the difference between the Emissions(in percent) in High income: nonOECD and Emissions(in percent) in China?
Provide a succinct answer. 38.26. In the year 1994, what is the difference between the Emissions(in percent) of High income: nonOECD and Emissions(in percent) of Singapore?
Your answer should be compact. 34.64. In the year 1994, what is the difference between the Emissions(in percent) in China and Emissions(in percent) in Singapore?
Provide a short and direct response. -3.62. In the year 1995, what is the difference between the Emissions(in percent) of Euro area and Emissions(in percent) of High income: nonOECD?
Ensure brevity in your answer.  -20.4. In the year 1995, what is the difference between the Emissions(in percent) of Euro area and Emissions(in percent) of China?
Offer a very short reply. 18.07. In the year 1995, what is the difference between the Emissions(in percent) in Euro area and Emissions(in percent) in Singapore?
Your answer should be very brief. 12.17. In the year 1995, what is the difference between the Emissions(in percent) of High income: nonOECD and Emissions(in percent) of China?
Your answer should be very brief. 38.47. In the year 1995, what is the difference between the Emissions(in percent) in High income: nonOECD and Emissions(in percent) in Singapore?
Your response must be concise. 32.56. In the year 1995, what is the difference between the Emissions(in percent) of China and Emissions(in percent) of Singapore?
Offer a terse response. -5.91. In the year 1996, what is the difference between the Emissions(in percent) in Euro area and Emissions(in percent) in High income: nonOECD?
Give a very brief answer. -20.72. In the year 1996, what is the difference between the Emissions(in percent) of Euro area and Emissions(in percent) of China?
Ensure brevity in your answer.  19.26. In the year 1996, what is the difference between the Emissions(in percent) of Euro area and Emissions(in percent) of Singapore?
Give a very brief answer. 15.09. In the year 1996, what is the difference between the Emissions(in percent) in High income: nonOECD and Emissions(in percent) in China?
Offer a terse response. 39.98. In the year 1996, what is the difference between the Emissions(in percent) of High income: nonOECD and Emissions(in percent) of Singapore?
Your response must be concise. 35.81. In the year 1996, what is the difference between the Emissions(in percent) in China and Emissions(in percent) in Singapore?
Ensure brevity in your answer.  -4.17. In the year 1997, what is the difference between the Emissions(in percent) in Euro area and Emissions(in percent) in High income: nonOECD?
Your response must be concise. -21.87. In the year 1997, what is the difference between the Emissions(in percent) in Euro area and Emissions(in percent) in China?
Make the answer very short. 19.26. In the year 1997, what is the difference between the Emissions(in percent) in Euro area and Emissions(in percent) in Singapore?
Your answer should be very brief. 16.23. In the year 1997, what is the difference between the Emissions(in percent) of High income: nonOECD and Emissions(in percent) of China?
Provide a short and direct response. 41.12. In the year 1997, what is the difference between the Emissions(in percent) in High income: nonOECD and Emissions(in percent) in Singapore?
Keep it short and to the point. 38.1. In the year 1997, what is the difference between the Emissions(in percent) in China and Emissions(in percent) in Singapore?
Make the answer very short. -3.03. In the year 1998, what is the difference between the Emissions(in percent) in Euro area and Emissions(in percent) in High income: nonOECD?
Provide a short and direct response. -21.6. In the year 1998, what is the difference between the Emissions(in percent) of Euro area and Emissions(in percent) of China?
Keep it short and to the point. 19.42. In the year 1998, what is the difference between the Emissions(in percent) of Euro area and Emissions(in percent) of Singapore?
Offer a terse response. 15.25. In the year 1998, what is the difference between the Emissions(in percent) of High income: nonOECD and Emissions(in percent) of China?
Your answer should be very brief. 41.02. In the year 1998, what is the difference between the Emissions(in percent) of High income: nonOECD and Emissions(in percent) of Singapore?
Keep it short and to the point. 36.85. In the year 1998, what is the difference between the Emissions(in percent) of China and Emissions(in percent) of Singapore?
Make the answer very short. -4.17. In the year 1999, what is the difference between the Emissions(in percent) in Euro area and Emissions(in percent) in High income: nonOECD?
Provide a succinct answer. -20.01. In the year 1999, what is the difference between the Emissions(in percent) in Euro area and Emissions(in percent) in China?
Offer a terse response. 20.23. In the year 1999, what is the difference between the Emissions(in percent) of Euro area and Emissions(in percent) of Singapore?
Make the answer very short. 16.58. In the year 1999, what is the difference between the Emissions(in percent) in High income: nonOECD and Emissions(in percent) in China?
Your answer should be compact. 40.25. In the year 1999, what is the difference between the Emissions(in percent) in High income: nonOECD and Emissions(in percent) in Singapore?
Ensure brevity in your answer.  36.59. In the year 1999, what is the difference between the Emissions(in percent) of China and Emissions(in percent) of Singapore?
Offer a terse response. -3.66. In the year 2000, what is the difference between the Emissions(in percent) of Euro area and Emissions(in percent) of High income: nonOECD?
Ensure brevity in your answer.  -18. In the year 2000, what is the difference between the Emissions(in percent) of Euro area and Emissions(in percent) of China?
Ensure brevity in your answer.  20.65. In the year 2000, what is the difference between the Emissions(in percent) in Euro area and Emissions(in percent) in Singapore?
Offer a very short reply. 16.88. In the year 2000, what is the difference between the Emissions(in percent) of High income: nonOECD and Emissions(in percent) of China?
Provide a succinct answer. 38.65. In the year 2000, what is the difference between the Emissions(in percent) of High income: nonOECD and Emissions(in percent) of Singapore?
Offer a terse response. 34.87. In the year 2000, what is the difference between the Emissions(in percent) of China and Emissions(in percent) of Singapore?
Ensure brevity in your answer.  -3.77. What is the ratio of the Emissions(in percent) in High income: nonOECD in 1993 to that in 1994?
Offer a terse response. 0.96. What is the ratio of the Emissions(in percent) of China in 1993 to that in 1994?
Provide a succinct answer. 0.91. What is the ratio of the Emissions(in percent) in Singapore in 1993 to that in 1994?
Your answer should be compact. 1. What is the ratio of the Emissions(in percent) in Euro area in 1993 to that in 1995?
Your answer should be compact. 0.94. What is the ratio of the Emissions(in percent) in High income: nonOECD in 1993 to that in 1995?
Provide a succinct answer. 0.96. What is the ratio of the Emissions(in percent) in China in 1993 to that in 1995?
Offer a very short reply. 0.97. What is the ratio of the Emissions(in percent) in Singapore in 1993 to that in 1995?
Provide a succinct answer. 0.7. What is the ratio of the Emissions(in percent) in Euro area in 1993 to that in 1996?
Your answer should be compact. 0.88. What is the ratio of the Emissions(in percent) of High income: nonOECD in 1993 to that in 1996?
Provide a short and direct response. 0.93. What is the ratio of the Emissions(in percent) in China in 1993 to that in 1996?
Provide a short and direct response. 0.97. What is the ratio of the Emissions(in percent) in Singapore in 1993 to that in 1996?
Give a very brief answer. 0.92. What is the ratio of the Emissions(in percent) of Euro area in 1993 to that in 1997?
Provide a succinct answer. 0.88. What is the ratio of the Emissions(in percent) of High income: nonOECD in 1993 to that in 1997?
Your answer should be very brief. 0.9. What is the ratio of the Emissions(in percent) of China in 1993 to that in 1997?
Your response must be concise. 0.98. What is the ratio of the Emissions(in percent) of Singapore in 1993 to that in 1997?
Ensure brevity in your answer.  1.16. What is the ratio of the Emissions(in percent) in Euro area in 1993 to that in 1998?
Your answer should be compact. 0.86. What is the ratio of the Emissions(in percent) in High income: nonOECD in 1993 to that in 1998?
Your response must be concise. 0.9. What is the ratio of the Emissions(in percent) of China in 1993 to that in 1998?
Your answer should be compact. 0.82. What is the ratio of the Emissions(in percent) in Singapore in 1993 to that in 1998?
Give a very brief answer. 0.88. What is the ratio of the Emissions(in percent) of Euro area in 1993 to that in 1999?
Keep it short and to the point. 0.83. What is the ratio of the Emissions(in percent) in High income: nonOECD in 1993 to that in 1999?
Your response must be concise. 0.91. What is the ratio of the Emissions(in percent) of China in 1993 to that in 1999?
Provide a succinct answer. 0.75. What is the ratio of the Emissions(in percent) in Singapore in 1993 to that in 1999?
Provide a short and direct response. 0.94. What is the ratio of the Emissions(in percent) of Euro area in 1993 to that in 2000?
Ensure brevity in your answer.  0.81. What is the ratio of the Emissions(in percent) of High income: nonOECD in 1993 to that in 2000?
Your response must be concise. 0.94. What is the ratio of the Emissions(in percent) of China in 1993 to that in 2000?
Offer a terse response. 0.71. What is the ratio of the Emissions(in percent) of Singapore in 1993 to that in 2000?
Make the answer very short. 0.9. What is the ratio of the Emissions(in percent) in Euro area in 1994 to that in 1995?
Provide a short and direct response. 0.93. What is the ratio of the Emissions(in percent) of China in 1994 to that in 1995?
Ensure brevity in your answer.  1.06. What is the ratio of the Emissions(in percent) of Singapore in 1994 to that in 1995?
Ensure brevity in your answer.  0.69. What is the ratio of the Emissions(in percent) in Euro area in 1994 to that in 1996?
Your response must be concise. 0.88. What is the ratio of the Emissions(in percent) of High income: nonOECD in 1994 to that in 1996?
Give a very brief answer. 0.96. What is the ratio of the Emissions(in percent) of China in 1994 to that in 1996?
Ensure brevity in your answer.  1.06. What is the ratio of the Emissions(in percent) in Singapore in 1994 to that in 1996?
Make the answer very short. 0.91. What is the ratio of the Emissions(in percent) of Euro area in 1994 to that in 1997?
Provide a short and direct response. 0.88. What is the ratio of the Emissions(in percent) in High income: nonOECD in 1994 to that in 1997?
Make the answer very short. 0.93. What is the ratio of the Emissions(in percent) in China in 1994 to that in 1997?
Offer a very short reply. 1.07. What is the ratio of the Emissions(in percent) of Singapore in 1994 to that in 1997?
Your response must be concise. 1.16. What is the ratio of the Emissions(in percent) in Euro area in 1994 to that in 1998?
Ensure brevity in your answer.  0.86. What is the ratio of the Emissions(in percent) of High income: nonOECD in 1994 to that in 1998?
Make the answer very short. 0.93. What is the ratio of the Emissions(in percent) of China in 1994 to that in 1998?
Offer a terse response. 0.89. What is the ratio of the Emissions(in percent) of Singapore in 1994 to that in 1998?
Provide a succinct answer. 0.87. What is the ratio of the Emissions(in percent) in Euro area in 1994 to that in 1999?
Give a very brief answer. 0.83. What is the ratio of the Emissions(in percent) of High income: nonOECD in 1994 to that in 1999?
Provide a succinct answer. 0.95. What is the ratio of the Emissions(in percent) in China in 1994 to that in 1999?
Provide a succinct answer. 0.83. What is the ratio of the Emissions(in percent) in Singapore in 1994 to that in 1999?
Keep it short and to the point. 0.94. What is the ratio of the Emissions(in percent) of Euro area in 1994 to that in 2000?
Offer a very short reply. 0.81. What is the ratio of the Emissions(in percent) in High income: nonOECD in 1994 to that in 2000?
Your answer should be very brief. 0.98. What is the ratio of the Emissions(in percent) in China in 1994 to that in 2000?
Your response must be concise. 0.77. What is the ratio of the Emissions(in percent) of Singapore in 1994 to that in 2000?
Your answer should be compact. 0.9. What is the ratio of the Emissions(in percent) in Euro area in 1995 to that in 1996?
Ensure brevity in your answer.  0.94. What is the ratio of the Emissions(in percent) of High income: nonOECD in 1995 to that in 1996?
Ensure brevity in your answer.  0.96. What is the ratio of the Emissions(in percent) of China in 1995 to that in 1996?
Offer a very short reply. 1. What is the ratio of the Emissions(in percent) in Singapore in 1995 to that in 1996?
Your answer should be compact. 1.32. What is the ratio of the Emissions(in percent) of Euro area in 1995 to that in 1997?
Your answer should be compact. 0.94. What is the ratio of the Emissions(in percent) in Singapore in 1995 to that in 1997?
Provide a short and direct response. 1.67. What is the ratio of the Emissions(in percent) in Euro area in 1995 to that in 1998?
Offer a very short reply. 0.92. What is the ratio of the Emissions(in percent) in High income: nonOECD in 1995 to that in 1998?
Give a very brief answer. 0.93. What is the ratio of the Emissions(in percent) of China in 1995 to that in 1998?
Make the answer very short. 0.84. What is the ratio of the Emissions(in percent) of Singapore in 1995 to that in 1998?
Keep it short and to the point. 1.26. What is the ratio of the Emissions(in percent) in Euro area in 1995 to that in 1999?
Offer a terse response. 0.88. What is the ratio of the Emissions(in percent) in High income: nonOECD in 1995 to that in 1999?
Your response must be concise. 0.95. What is the ratio of the Emissions(in percent) of China in 1995 to that in 1999?
Offer a terse response. 0.78. What is the ratio of the Emissions(in percent) of Singapore in 1995 to that in 1999?
Your response must be concise. 1.35. What is the ratio of the Emissions(in percent) in Euro area in 1995 to that in 2000?
Keep it short and to the point. 0.86. What is the ratio of the Emissions(in percent) in High income: nonOECD in 1995 to that in 2000?
Your answer should be compact. 0.98. What is the ratio of the Emissions(in percent) of China in 1995 to that in 2000?
Your answer should be very brief. 0.73. What is the ratio of the Emissions(in percent) in Singapore in 1995 to that in 2000?
Your answer should be compact. 1.3. What is the ratio of the Emissions(in percent) in High income: nonOECD in 1996 to that in 1997?
Your answer should be very brief. 0.97. What is the ratio of the Emissions(in percent) in China in 1996 to that in 1997?
Make the answer very short. 1.01. What is the ratio of the Emissions(in percent) in Singapore in 1996 to that in 1997?
Your answer should be very brief. 1.27. What is the ratio of the Emissions(in percent) in Euro area in 1996 to that in 1998?
Your answer should be very brief. 0.98. What is the ratio of the Emissions(in percent) of High income: nonOECD in 1996 to that in 1998?
Make the answer very short. 0.97. What is the ratio of the Emissions(in percent) in China in 1996 to that in 1998?
Your answer should be compact. 0.85. What is the ratio of the Emissions(in percent) of Euro area in 1996 to that in 1999?
Provide a short and direct response. 0.94. What is the ratio of the Emissions(in percent) in High income: nonOECD in 1996 to that in 1999?
Ensure brevity in your answer.  0.99. What is the ratio of the Emissions(in percent) of China in 1996 to that in 1999?
Keep it short and to the point. 0.78. What is the ratio of the Emissions(in percent) in Singapore in 1996 to that in 1999?
Your answer should be compact. 1.03. What is the ratio of the Emissions(in percent) in Euro area in 1996 to that in 2000?
Make the answer very short. 0.92. What is the ratio of the Emissions(in percent) in High income: nonOECD in 1996 to that in 2000?
Provide a short and direct response. 1.02. What is the ratio of the Emissions(in percent) in China in 1996 to that in 2000?
Your response must be concise. 0.73. What is the ratio of the Emissions(in percent) of Singapore in 1996 to that in 2000?
Give a very brief answer. 0.99. What is the ratio of the Emissions(in percent) of Euro area in 1997 to that in 1998?
Give a very brief answer. 0.98. What is the ratio of the Emissions(in percent) of China in 1997 to that in 1998?
Give a very brief answer. 0.84. What is the ratio of the Emissions(in percent) in Singapore in 1997 to that in 1998?
Your response must be concise. 0.76. What is the ratio of the Emissions(in percent) in Euro area in 1997 to that in 1999?
Give a very brief answer. 0.94. What is the ratio of the Emissions(in percent) of High income: nonOECD in 1997 to that in 1999?
Your response must be concise. 1.01. What is the ratio of the Emissions(in percent) in China in 1997 to that in 1999?
Provide a succinct answer. 0.77. What is the ratio of the Emissions(in percent) of Singapore in 1997 to that in 1999?
Make the answer very short. 0.81. What is the ratio of the Emissions(in percent) of Euro area in 1997 to that in 2000?
Keep it short and to the point. 0.92. What is the ratio of the Emissions(in percent) in High income: nonOECD in 1997 to that in 2000?
Make the answer very short. 1.05. What is the ratio of the Emissions(in percent) in China in 1997 to that in 2000?
Keep it short and to the point. 0.72. What is the ratio of the Emissions(in percent) of Singapore in 1997 to that in 2000?
Your answer should be very brief. 0.78. What is the ratio of the Emissions(in percent) of Euro area in 1998 to that in 1999?
Keep it short and to the point. 0.96. What is the ratio of the Emissions(in percent) of High income: nonOECD in 1998 to that in 1999?
Offer a very short reply. 1.02. What is the ratio of the Emissions(in percent) of China in 1998 to that in 1999?
Make the answer very short. 0.92. What is the ratio of the Emissions(in percent) of Singapore in 1998 to that in 1999?
Make the answer very short. 1.07. What is the ratio of the Emissions(in percent) in Euro area in 1998 to that in 2000?
Ensure brevity in your answer.  0.93. What is the ratio of the Emissions(in percent) of High income: nonOECD in 1998 to that in 2000?
Provide a short and direct response. 1.05. What is the ratio of the Emissions(in percent) in China in 1998 to that in 2000?
Your answer should be very brief. 0.87. What is the ratio of the Emissions(in percent) in Euro area in 1999 to that in 2000?
Your answer should be very brief. 0.98. What is the ratio of the Emissions(in percent) of High income: nonOECD in 1999 to that in 2000?
Provide a succinct answer. 1.04. What is the ratio of the Emissions(in percent) of China in 1999 to that in 2000?
Offer a terse response. 0.94. What is the ratio of the Emissions(in percent) in Singapore in 1999 to that in 2000?
Your response must be concise. 0.96. What is the difference between the highest and the second highest Emissions(in percent) of Euro area?
Ensure brevity in your answer.  0.53. What is the difference between the highest and the second highest Emissions(in percent) in High income: nonOECD?
Your answer should be compact. 0.14. What is the difference between the highest and the second highest Emissions(in percent) in China?
Make the answer very short. 0.11. What is the difference between the highest and the second highest Emissions(in percent) of Singapore?
Provide a short and direct response. 1.49. What is the difference between the highest and the lowest Emissions(in percent) in Euro area?
Ensure brevity in your answer.  4.31. What is the difference between the highest and the lowest Emissions(in percent) of High income: nonOECD?
Provide a succinct answer. 4.35. What is the difference between the highest and the lowest Emissions(in percent) of China?
Ensure brevity in your answer.  0.52. What is the difference between the highest and the lowest Emissions(in percent) in Singapore?
Your response must be concise. 2.88. 